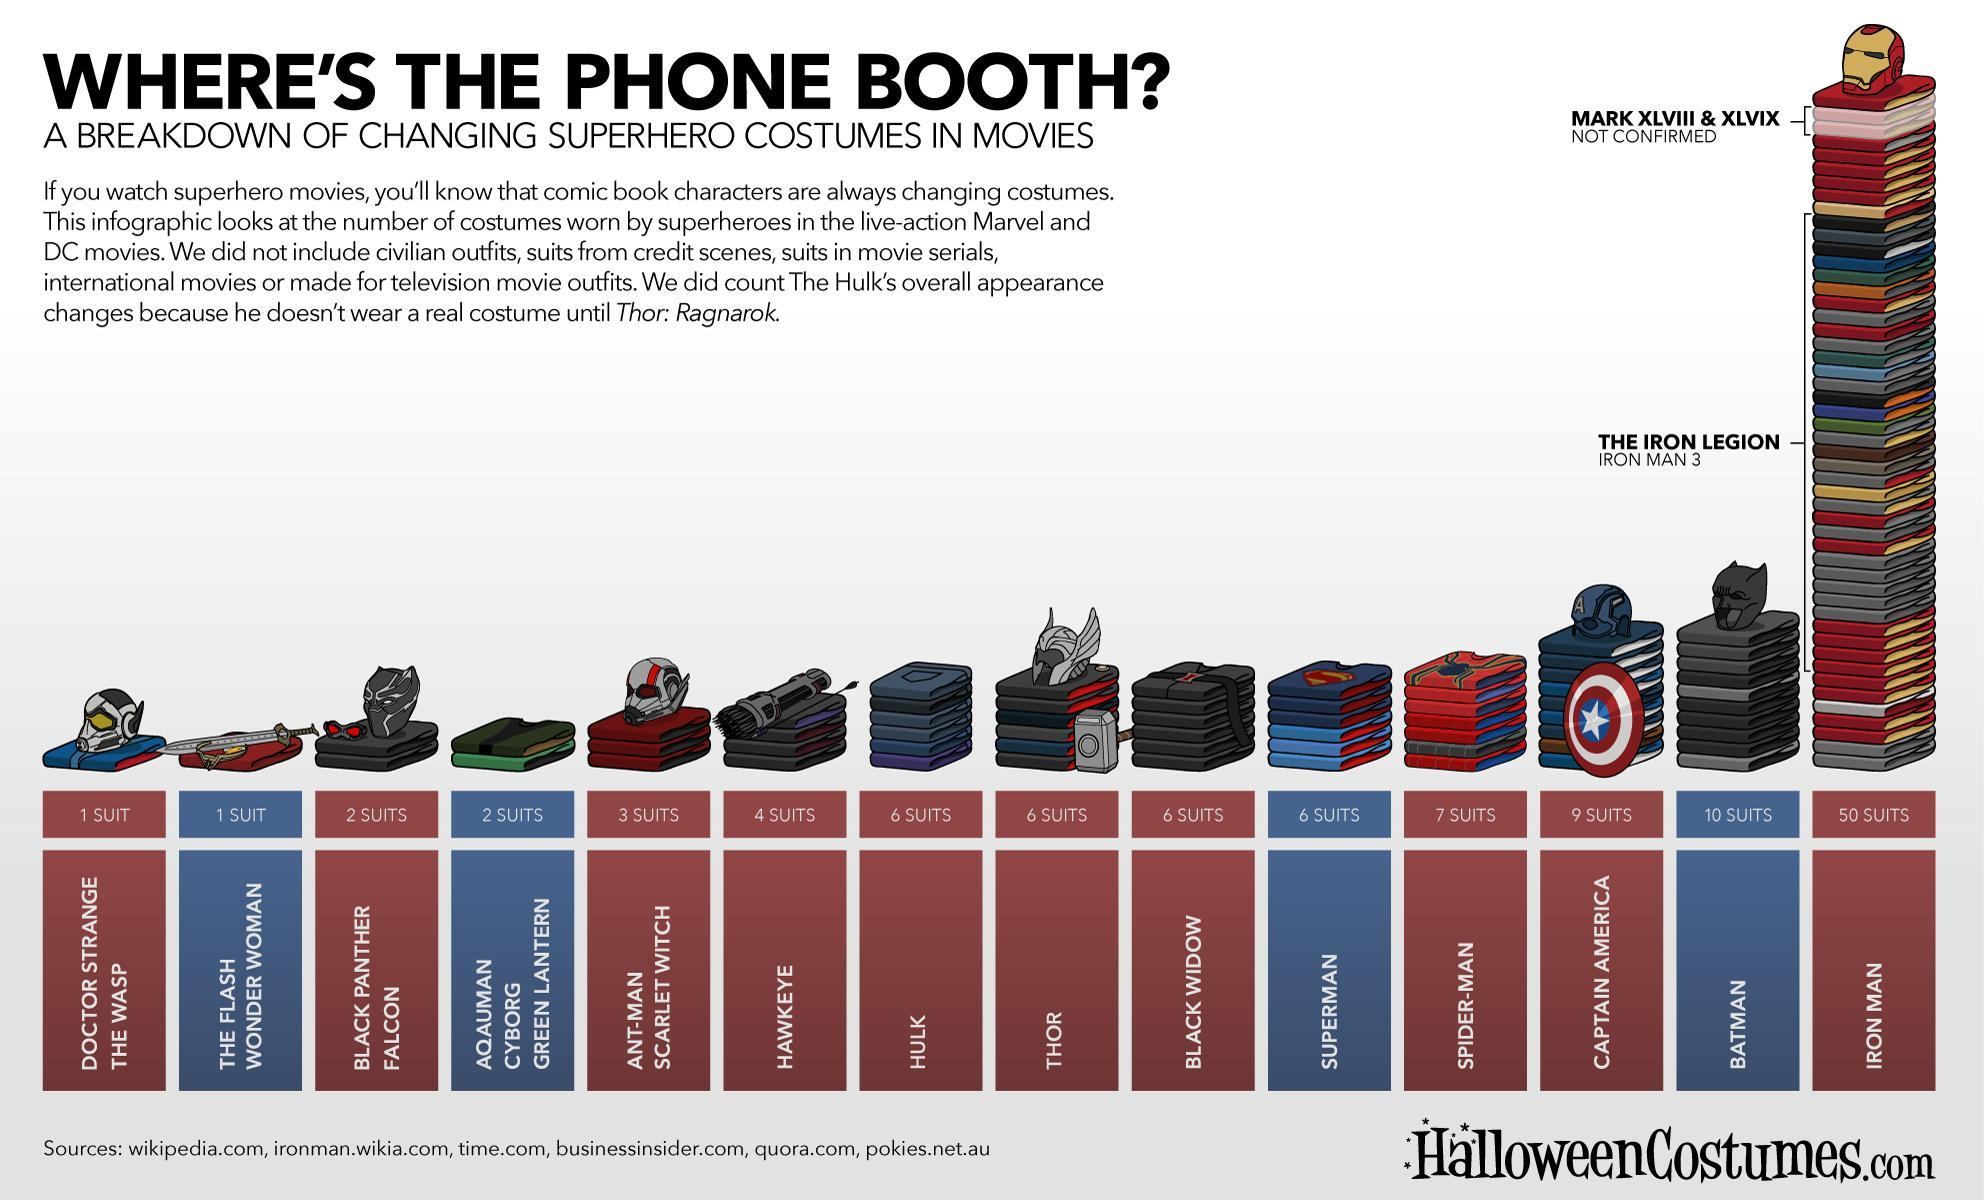What is the number of suits worn by Hulk and Thor, taken together?
Answer the question with a short phrase. 12 What is the number of suits worn by Superman and Batman, taken together? 16 What is the number of suits worn by Blackwidow and Hawkeye, taken together? 10 What is the number of suits worn by Spider-Man and IronMan, taken together? 57 